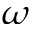Convert formula to latex. <formula><loc_0><loc_0><loc_500><loc_500>\omega</formula> 